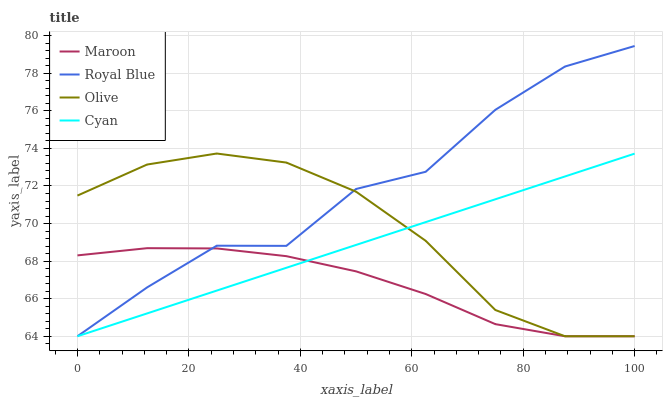Does Maroon have the minimum area under the curve?
Answer yes or no. Yes. Does Royal Blue have the maximum area under the curve?
Answer yes or no. Yes. Does Royal Blue have the minimum area under the curve?
Answer yes or no. No. Does Maroon have the maximum area under the curve?
Answer yes or no. No. Is Cyan the smoothest?
Answer yes or no. Yes. Is Royal Blue the roughest?
Answer yes or no. Yes. Is Maroon the smoothest?
Answer yes or no. No. Is Maroon the roughest?
Answer yes or no. No. Does Olive have the lowest value?
Answer yes or no. Yes. Does Royal Blue have the highest value?
Answer yes or no. Yes. Does Maroon have the highest value?
Answer yes or no. No. Does Maroon intersect Cyan?
Answer yes or no. Yes. Is Maroon less than Cyan?
Answer yes or no. No. Is Maroon greater than Cyan?
Answer yes or no. No. 